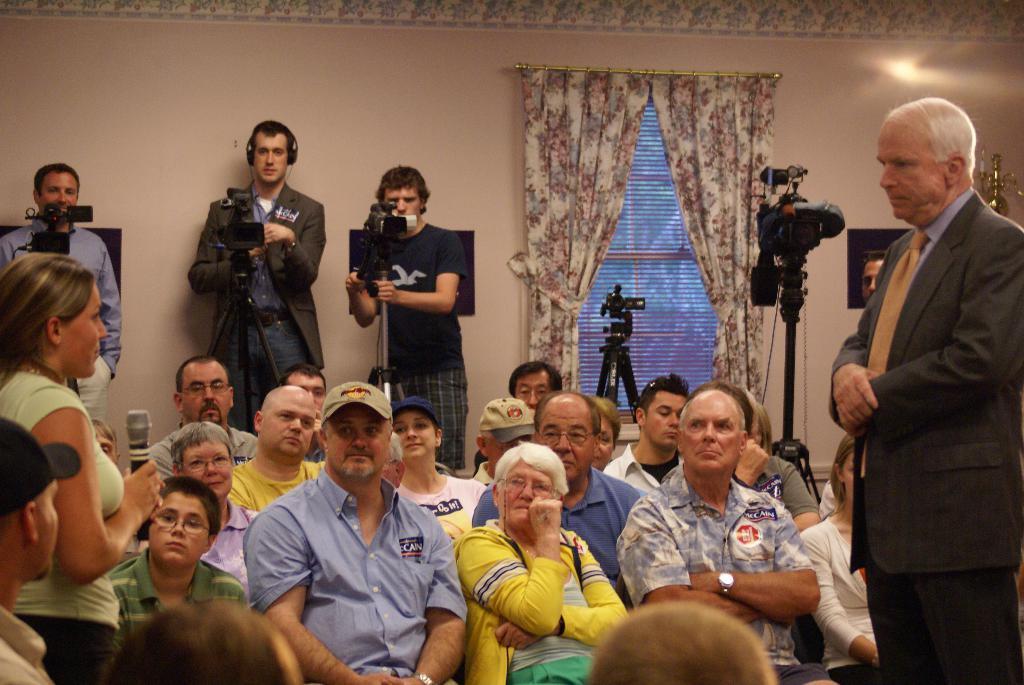Please provide a concise description of this image. This image is taken indoors. In the background there is a wall with a window, a window blind and curtains and there is a picture frame on the wall. On the right side of the image a man is standing on the floor. In the middle of the image a few people are sitting on the chairs and three men are standing and holding cameras in their hands. On the left side of the image a woman is standing and holding a mic in her hand. 